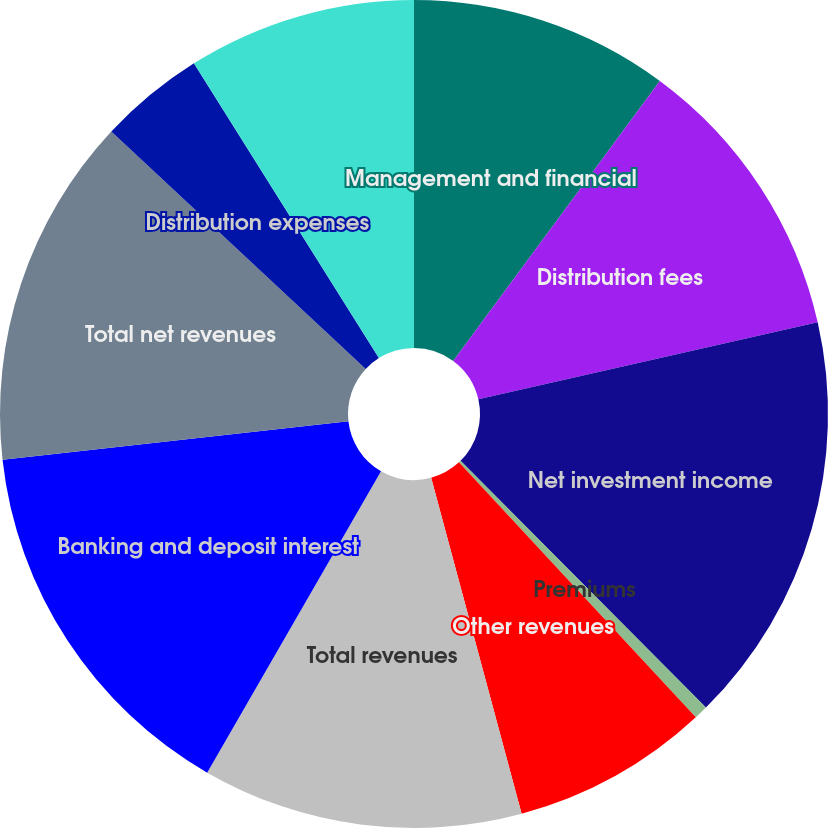<chart> <loc_0><loc_0><loc_500><loc_500><pie_chart><fcel>Management and financial<fcel>Distribution fees<fcel>Net investment income<fcel>Premiums<fcel>Other revenues<fcel>Total revenues<fcel>Banking and deposit interest<fcel>Total net revenues<fcel>Distribution expenses<fcel>Interest credited to fixed<nl><fcel>10.12%<fcel>11.32%<fcel>16.1%<fcel>0.54%<fcel>7.73%<fcel>12.51%<fcel>14.91%<fcel>13.71%<fcel>4.13%<fcel>8.92%<nl></chart> 